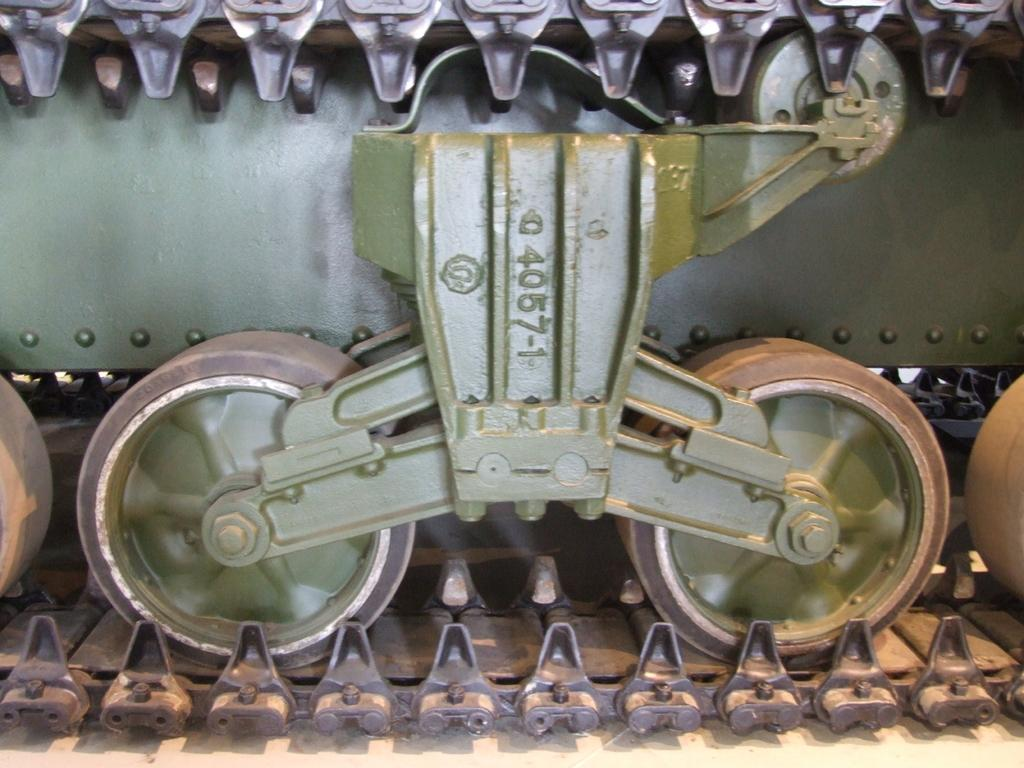What type of object is in the image? There is a vehicle in the image. Can you describe the appearance of the vehicle? The vehicle resembles a toy and appears to be a panzer tank. What features does the vehicle have? The vehicle has a wheel chain and wheels. How often does the vehicle need to be washed in the image? The image does not provide information about the vehicle's maintenance or cleaning requirements, so it cannot be determined from the image. 